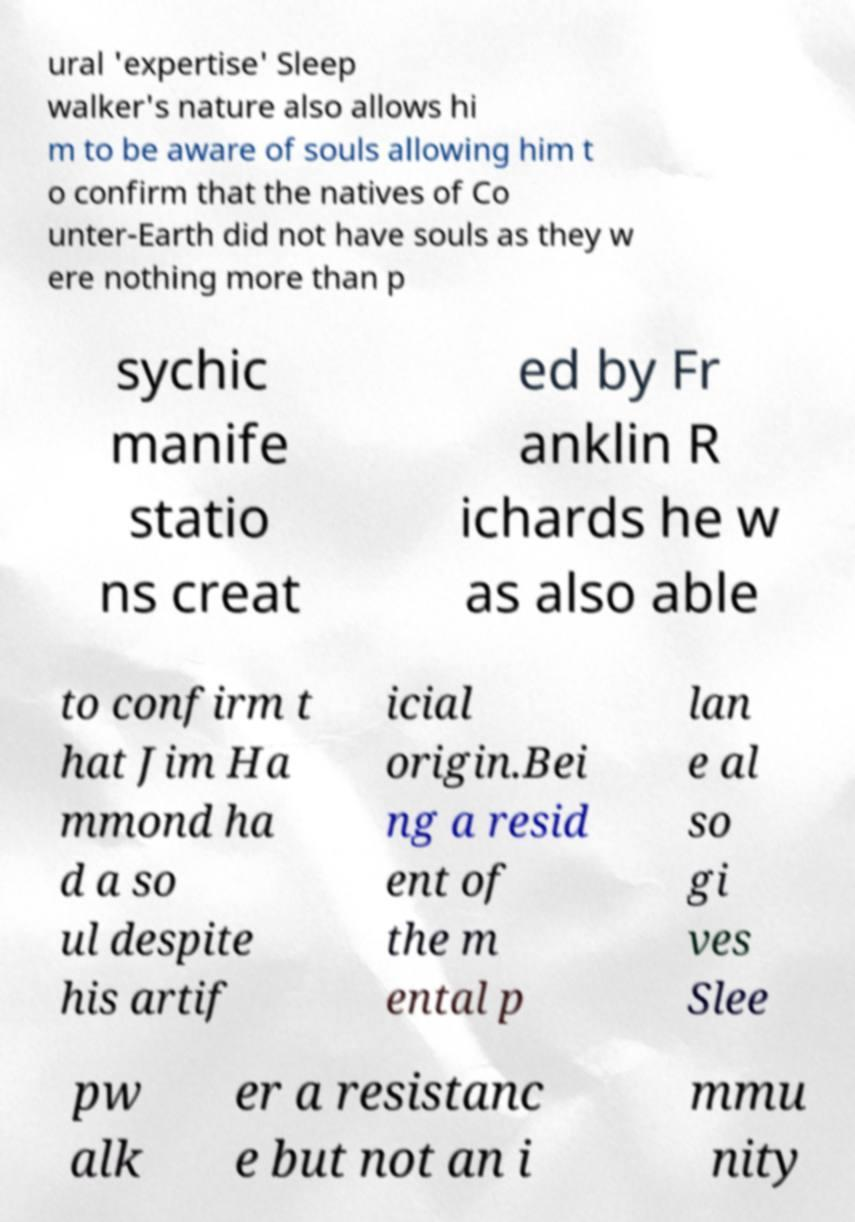There's text embedded in this image that I need extracted. Can you transcribe it verbatim? ural 'expertise' Sleep walker's nature also allows hi m to be aware of souls allowing him t o confirm that the natives of Co unter-Earth did not have souls as they w ere nothing more than p sychic manife statio ns creat ed by Fr anklin R ichards he w as also able to confirm t hat Jim Ha mmond ha d a so ul despite his artif icial origin.Bei ng a resid ent of the m ental p lan e al so gi ves Slee pw alk er a resistanc e but not an i mmu nity 